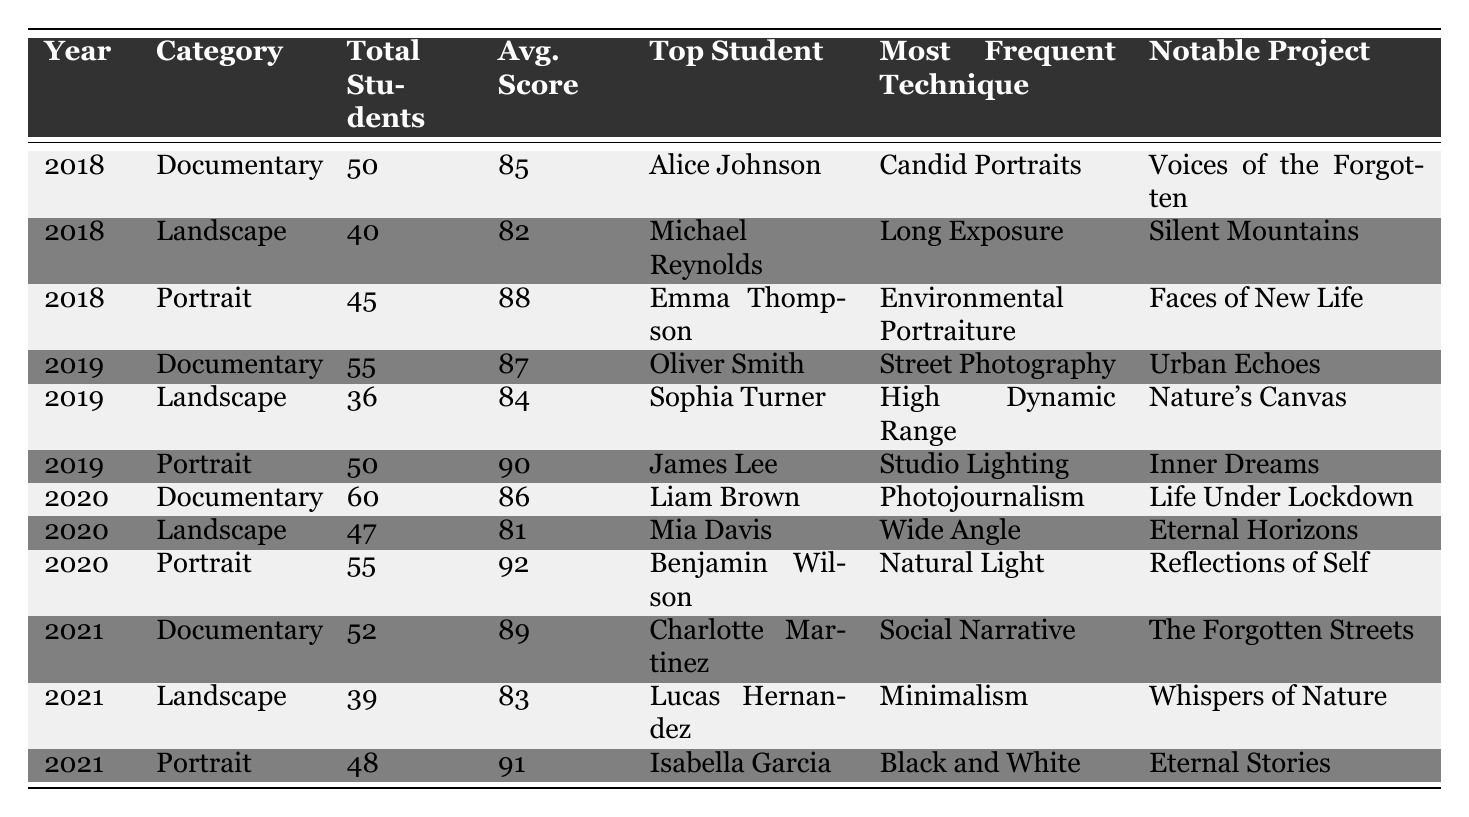What was the top student's name in the Portrait category for 2020? Referring to the table, under the year 2020 and the Portrait category, the top student is listed as Benjamin Wilson.
Answer: Benjamin Wilson How many total students participated in Documentary reviews in 2019? Looking at the year 2019 and the Documentary category in the table, the total number of students is given as 55.
Answer: 55 What was the average score for Landscape reviews across all years? To find the average score for Landscape, we add the average scores from each year: 82 (2018) + 84 (2019) + 81 (2020) + 83 (2021) = 330. There are four years, so the average is 330/4 = 82.5.
Answer: 82.5 Is there a student named Emma Thompson listed in the table? The table shows a student named Emma Thompson in the year 2018, specifically in the Portrait category. Therefore, the statement is true.
Answer: Yes How does the average score for the Portrait category in 2020 compare to the average score for the same category in 2019? The average score for Portrait in 2020 is 92, and in 2019 it is 90. Since 92 is greater than 90, the average score in 2020 is higher than in 2019 by a difference of 2 points.
Answer: Higher What notable project was associated with the top student in Landscape for 2021? In the year 2021 under the Landscape category, the top student is Lucas Hernandez, and his notable project is listed as "Whispers of Nature."
Answer: Whispers of Nature Which year had the highest total number of students across all categories, and what was that number? By adding total students from each category for every year, we find: 50 + 40 + 45 = 135 (2018), 55 + 36 + 50 = 141 (2019), 60 + 47 + 55 = 162 (2020), and 52 + 39 + 48 = 139 (2021). The highest total is 162 in 2020.
Answer: 2020, 162 Which category had the most students in the year 2018? In 2018, the totals were Documentary: 50, Landscape: 40, Portrait: 45. The highest among these is Documentary with 50 students.
Answer: Documentary What was the common technique used by the top student in the Documentary category for 2021? For the year 2021 and in the Documentary category, it states that the most frequent technique used by top student Charlotte Martinez was "Social Narrative."
Answer: Social Narrative In which category and year did the student with the notable project "Life Under Lockdown" achieve their top score? The notable project "Life Under Lockdown" is associated with the student Liam Brown in the year 2020 under the Documentary category, where the average score was 86.
Answer: Documentary 2020 